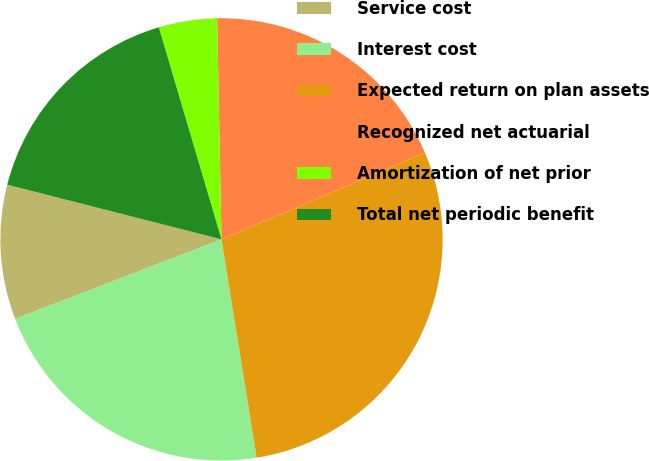Convert chart. <chart><loc_0><loc_0><loc_500><loc_500><pie_chart><fcel>Service cost<fcel>Interest cost<fcel>Expected return on plan assets<fcel>Recognized net actuarial<fcel>Amortization of net prior<fcel>Total net periodic benefit<nl><fcel>9.83%<fcel>21.69%<fcel>28.87%<fcel>18.91%<fcel>4.26%<fcel>16.45%<nl></chart> 